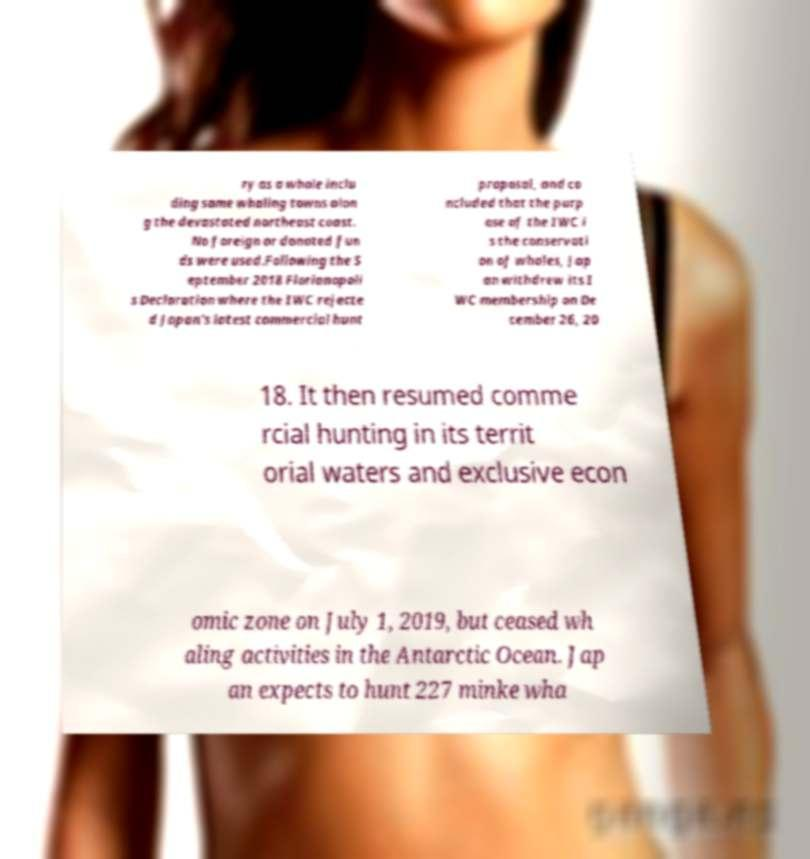What messages or text are displayed in this image? I need them in a readable, typed format. ry as a whole inclu ding some whaling towns alon g the devastated northeast coast. No foreign or donated fun ds were used.Following the S eptember 2018 Florianopoli s Declaration where the IWC rejecte d Japan's latest commercial hunt proposal, and co ncluded that the purp ose of the IWC i s the conservati on of whales, Jap an withdrew its I WC membership on De cember 26, 20 18. It then resumed comme rcial hunting in its territ orial waters and exclusive econ omic zone on July 1, 2019, but ceased wh aling activities in the Antarctic Ocean. Jap an expects to hunt 227 minke wha 